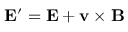<formula> <loc_0><loc_0><loc_500><loc_500>E ^ { \prime } = E + v \times B</formula> 